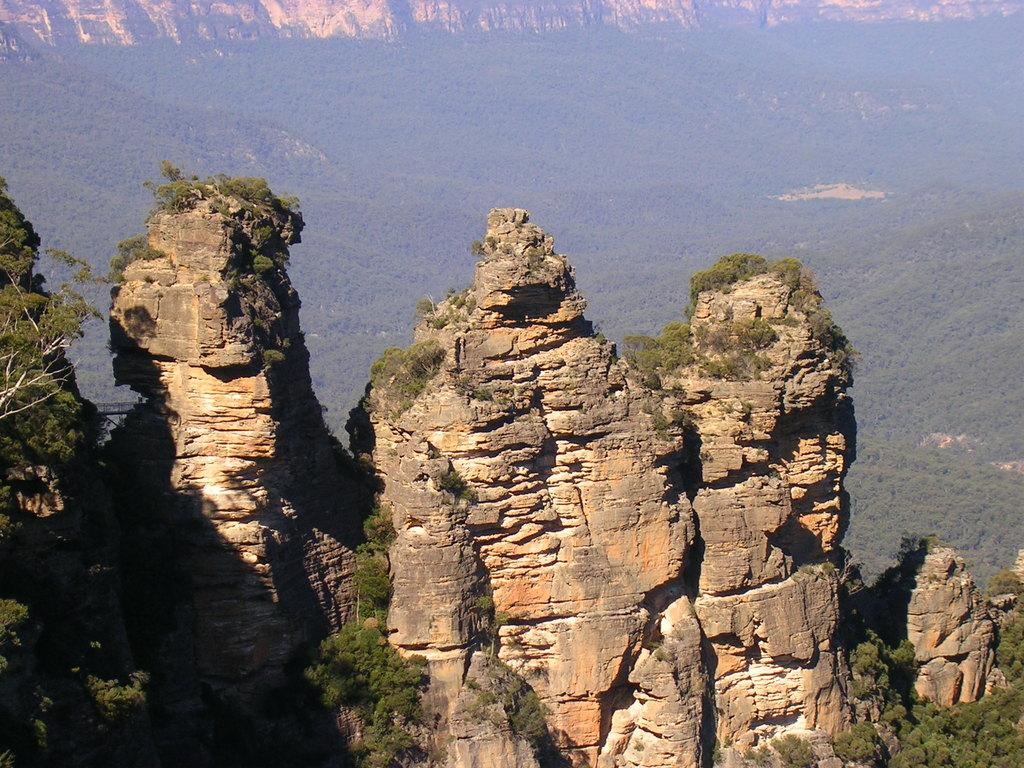What geographical feature is located in the center of the image? There are hills in the center of the image. What type of vegetation can be seen in the image? There are trees and plants in the image. What atmospheric condition is present in the image? There is fog in the image. What other objects can be seen in the image? There are a few other objects in the image. What type of disease is being treated in the image? There is no indication of a disease or any medical treatment in the image. What financial transactions are taking place in the image? There is no mention of credit, debt, or any financial transactions in the image. 